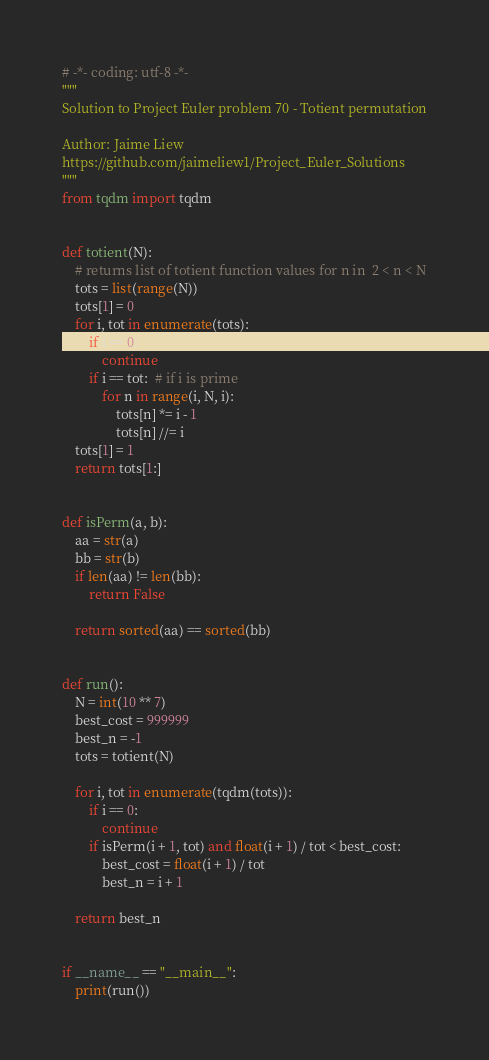<code> <loc_0><loc_0><loc_500><loc_500><_Python_># -*- coding: utf-8 -*-
"""
Solution to Project Euler problem 70 - Totient permutation

Author: Jaime Liew
https://github.com/jaimeliew1/Project_Euler_Solutions
"""
from tqdm import tqdm


def totient(N):
    # returns list of totient function values for n in  2 < n < N
    tots = list(range(N))
    tots[1] = 0
    for i, tot in enumerate(tots):
        if i == 0:
            continue
        if i == tot:  # if i is prime
            for n in range(i, N, i):
                tots[n] *= i - 1
                tots[n] //= i
    tots[1] = 1
    return tots[1:]


def isPerm(a, b):
    aa = str(a)
    bb = str(b)
    if len(aa) != len(bb):
        return False

    return sorted(aa) == sorted(bb)


def run():
    N = int(10 ** 7)
    best_cost = 999999
    best_n = -1
    tots = totient(N)

    for i, tot in enumerate(tqdm(tots)):
        if i == 0:
            continue
        if isPerm(i + 1, tot) and float(i + 1) / tot < best_cost:
            best_cost = float(i + 1) / tot
            best_n = i + 1

    return best_n


if __name__ == "__main__":
    print(run())
</code> 